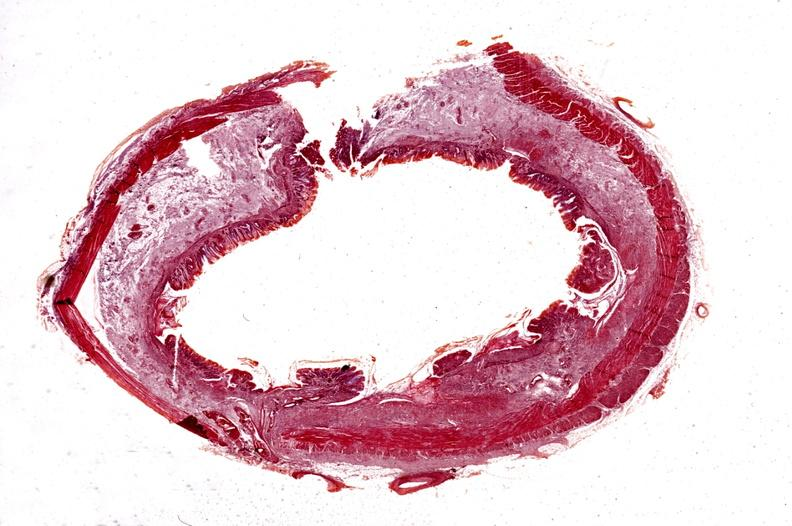does gangrene show colon, chronic ulcerative colitis?
Answer the question using a single word or phrase. No 